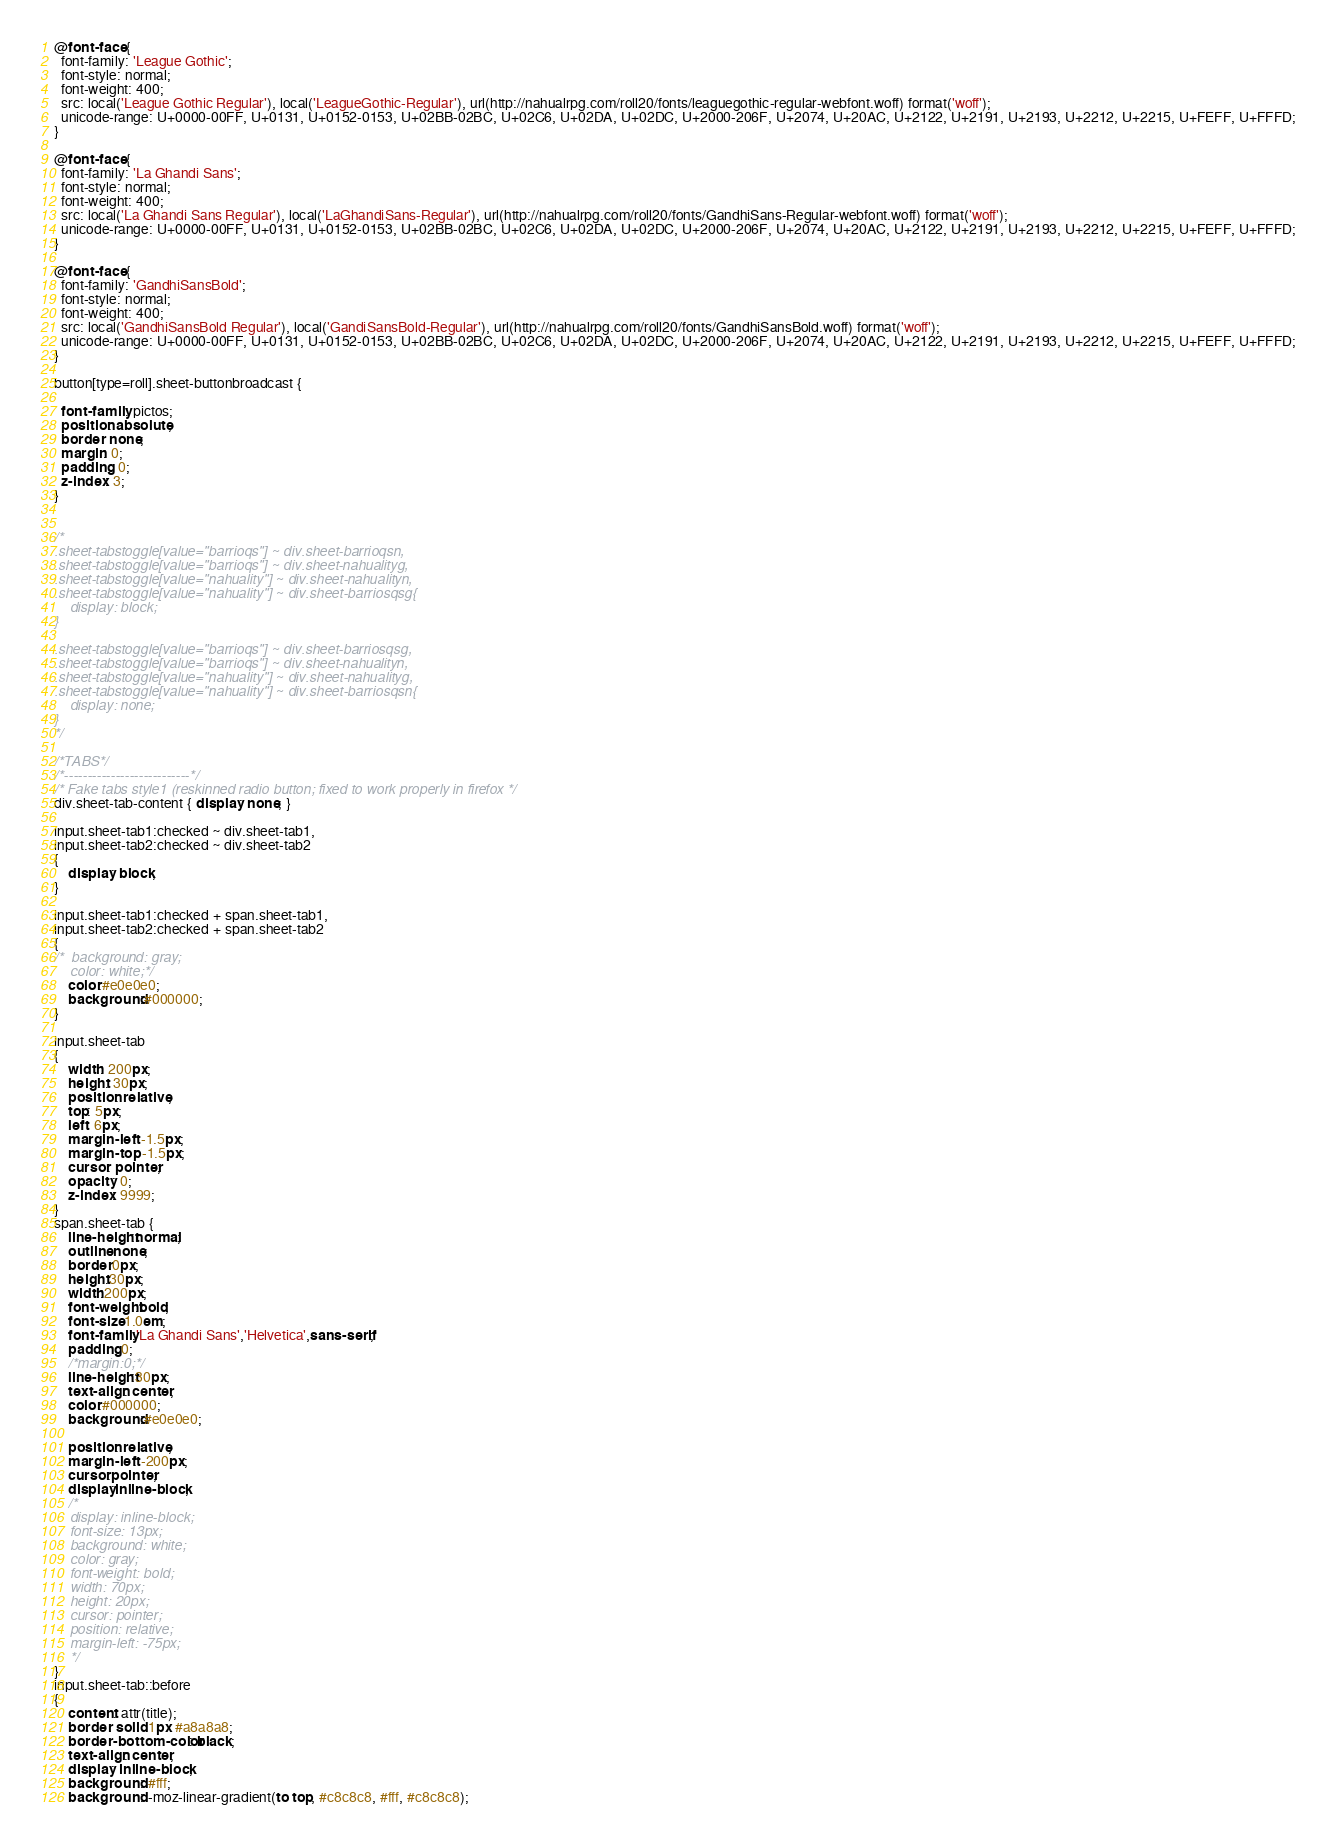Convert code to text. <code><loc_0><loc_0><loc_500><loc_500><_CSS_>@font-face {
  font-family: 'League Gothic';
  font-style: normal;
  font-weight: 400;
  src: local('League Gothic Regular'), local('LeagueGothic-Regular'), url(http://nahualrpg.com/roll20/fonts/leaguegothic-regular-webfont.woff) format('woff');
  unicode-range: U+0000-00FF, U+0131, U+0152-0153, U+02BB-02BC, U+02C6, U+02DA, U+02DC, U+2000-206F, U+2074, U+20AC, U+2122, U+2191, U+2193, U+2212, U+2215, U+FEFF, U+FFFD;
}

@font-face {
  font-family: 'La Ghandi Sans';
  font-style: normal;
  font-weight: 400;
  src: local('La Ghandi Sans Regular'), local('LaGhandiSans-Regular'), url(http://nahualrpg.com/roll20/fonts/GandhiSans-Regular-webfont.woff) format('woff');
  unicode-range: U+0000-00FF, U+0131, U+0152-0153, U+02BB-02BC, U+02C6, U+02DA, U+02DC, U+2000-206F, U+2074, U+20AC, U+2122, U+2191, U+2193, U+2212, U+2215, U+FEFF, U+FFFD;
}

@font-face {
  font-family: 'GandhiSansBold';
  font-style: normal;
  font-weight: 400;
  src: local('GandhiSansBold Regular'), local('GandiSansBold-Regular'), url(http://nahualrpg.com/roll20/fonts/GandhiSansBold.woff) format('woff');
  unicode-range: U+0000-00FF, U+0131, U+0152-0153, U+02BB-02BC, U+02C6, U+02DA, U+02DC, U+2000-206F, U+2074, U+20AC, U+2122, U+2191, U+2193, U+2212, U+2215, U+FEFF, U+FFFD;
}

button[type=roll].sheet-buttonbroadcast {

  font-family: pictos;
  position: absolute;
  border: none;
  margin: 0;
  padding: 0;
  z-index: 3;
}


/*
.sheet-tabstoggle[value="barrioqs"] ~ div.sheet-barrioqsn,
.sheet-tabstoggle[value="barrioqs"] ~ div.sheet-nahualityg,
.sheet-tabstoggle[value="nahuality"] ~ div.sheet-nahualityn, 
.sheet-tabstoggle[value="nahuality"] ~ div.sheet-barriosqsg{
	display: block;
}

.sheet-tabstoggle[value="barrioqs"] ~ div.sheet-barriosqsg,
.sheet-tabstoggle[value="barrioqs"] ~ div.sheet-nahualityn,
.sheet-tabstoggle[value="nahuality"] ~ div.sheet-nahualityg, 
.sheet-tabstoggle[value="nahuality"] ~ div.sheet-barriosqsn{
	display: none;
}
*/

/*TABS*/
/*---------------------------*/
/* Fake tabs style1 (reskinned radio button; fixed to work properly in firefox */
div.sheet-tab-content { display: none; }

input.sheet-tab1:checked ~ div.sheet-tab1,
input.sheet-tab2:checked ~ div.sheet-tab2
{
    display: block;
}

input.sheet-tab1:checked + span.sheet-tab1,
input.sheet-tab2:checked + span.sheet-tab2
{
/*	background: gray;
	color: white;*/
    color:#e0e0e0;
    background:#000000;	
}

input.sheet-tab
{
    width: 200px;
    height: 30px;
    position: relative;
    top: 5px;
    left: 6px;
    margin-left: -1.5px;
    margin-top: -1.5px;
    cursor: pointer;
	opacity: 0;
    z-index: 9999;
}
span.sheet-tab {
    line-height:normal;
    outline:none;
    border:0px;
    height:30px;
    width:200px;
    font-weight:bold;
    font-size:1.0em;
    font-family:'La Ghandi Sans','Helvetica',sans-serif;
    padding:0;
    /*margin:0;*/
    line-height:30px;    
	text-align: center;
	color:#000000;
	background:#e0e0e0;
	
	position: relative;
	margin-left: -200px;
	cursor:pointer;
	display:inline-block;
	/*
	display: inline-block;
	font-size: 13px;
	background: white;
	color: gray;
	font-weight: bold;
	width: 70px;
	height: 20px;
	cursor: pointer;
	position: relative;
	margin-left: -75px;
	*/
}
input.sheet-tab::before
{
    content: attr(title);
    border: solid 1px #a8a8a8;
    border-bottom-color: black;
    text-align: center;
    display: inline-block;
    background: #fff;
    background: -moz-linear-gradient(to top, #c8c8c8, #fff, #c8c8c8);</code> 